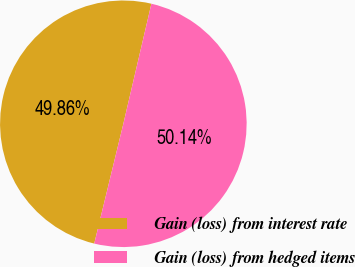<chart> <loc_0><loc_0><loc_500><loc_500><pie_chart><fcel>Gain (loss) from interest rate<fcel>Gain (loss) from hedged items<nl><fcel>49.86%<fcel>50.14%<nl></chart> 